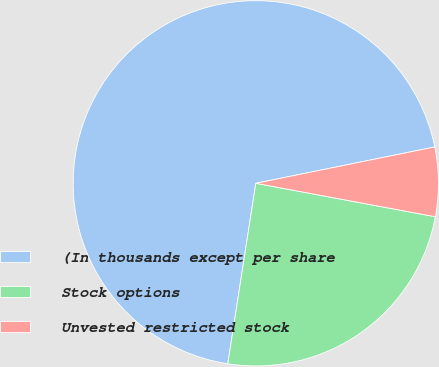<chart> <loc_0><loc_0><loc_500><loc_500><pie_chart><fcel>(In thousands except per share<fcel>Stock options<fcel>Unvested restricted stock<nl><fcel>69.36%<fcel>24.52%<fcel>6.12%<nl></chart> 